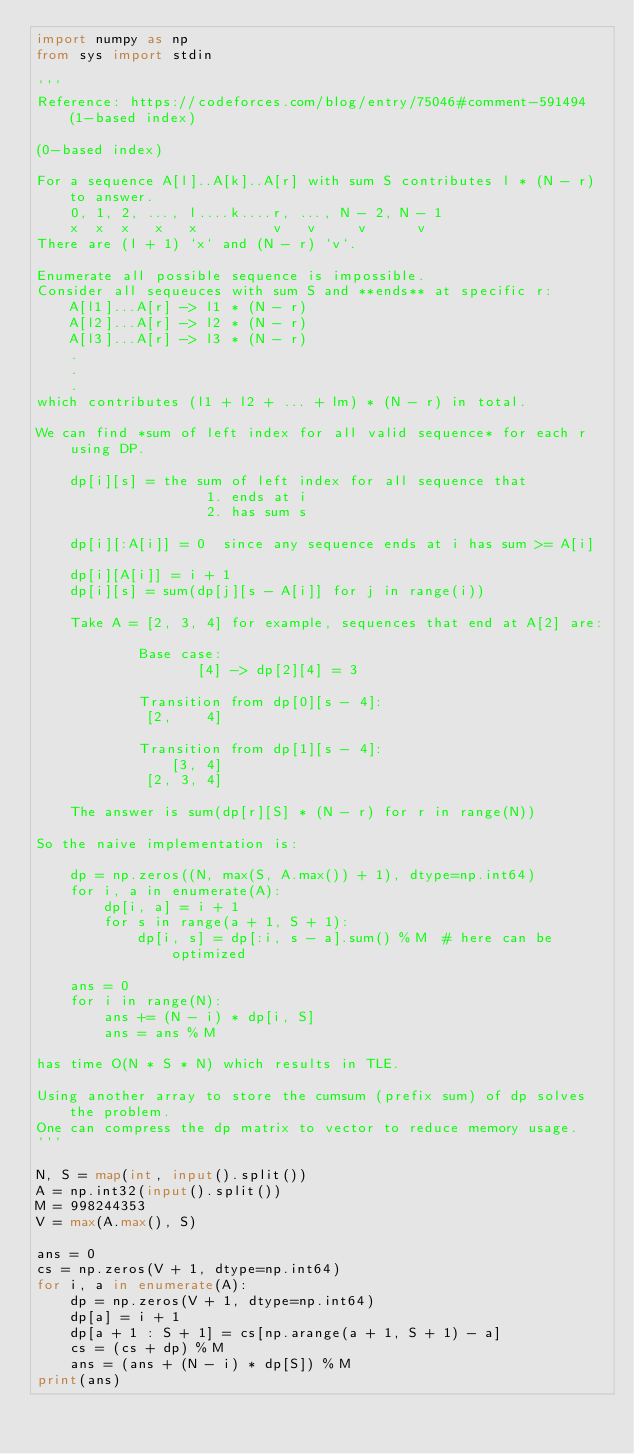<code> <loc_0><loc_0><loc_500><loc_500><_Python_>import numpy as np
from sys import stdin

'''
Reference: https://codeforces.com/blog/entry/75046#comment-591494 (1-based index)

(0-based index)

For a sequence A[l]..A[k]..A[r] with sum S contributes l * (N - r) to answer.
    0, 1, 2, ..., l....k....r, ..., N - 2, N - 1
    x  x  x   x   x         v   v     v      v
There are (l + 1) `x` and (N - r) `v`.

Enumerate all possible sequence is impossible. 
Consider all sequeuces with sum S and **ends** at specific r:
    A[l1]...A[r] -> l1 * (N - r)
    A[l2]...A[r] -> l2 * (N - r)
    A[l3]...A[r] -> l3 * (N - r)
    .
    .
    .
which contributes (l1 + l2 + ... + lm) * (N - r) in total.

We can find *sum of left index for all valid sequence* for each r using DP.

    dp[i][s] = the sum of left index for all sequence that
                    1. ends at i
                    2. has sum s
    
    dp[i][:A[i]] = 0  since any sequence ends at i has sum >= A[i]

    dp[i][A[i]] = i + 1
    dp[i][s] = sum(dp[j][s - A[i]] for j in range(i))

    Take A = [2, 3, 4] for example, sequences that end at A[2] are:
    
            Base case:
                   [4] -> dp[2][4] = 3

            Transition from dp[0][s - 4]:
             [2,    4]

            Transition from dp[1][s - 4]:
                [3, 4]
             [2, 3, 4]
    
    The answer is sum(dp[r][S] * (N - r) for r in range(N))

So the naive implementation is:

    dp = np.zeros((N, max(S, A.max()) + 1), dtype=np.int64)
    for i, a in enumerate(A):
        dp[i, a] = i + 1
        for s in range(a + 1, S + 1):
            dp[i, s] = dp[:i, s - a].sum() % M  # here can be optimized
    
    ans = 0
    for i in range(N):
        ans += (N - i) * dp[i, S]
        ans = ans % M

has time O(N * S * N) which results in TLE.

Using another array to store the cumsum (prefix sum) of dp solves the problem.
One can compress the dp matrix to vector to reduce memory usage.
'''

N, S = map(int, input().split())
A = np.int32(input().split())
M = 998244353
V = max(A.max(), S)

ans = 0
cs = np.zeros(V + 1, dtype=np.int64)
for i, a in enumerate(A):
    dp = np.zeros(V + 1, dtype=np.int64)
    dp[a] = i + 1
    dp[a + 1 : S + 1] = cs[np.arange(a + 1, S + 1) - a]
    cs = (cs + dp) % M
    ans = (ans + (N - i) * dp[S]) % M
print(ans)
</code> 